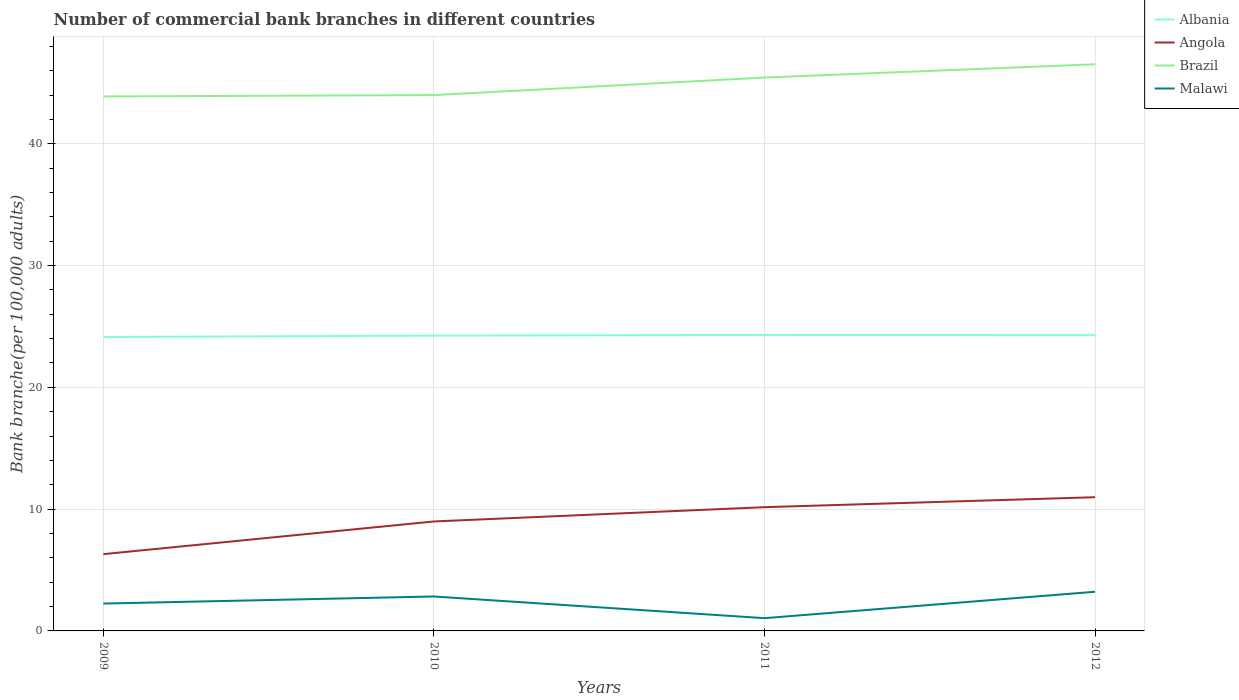How many different coloured lines are there?
Offer a very short reply. 4. Does the line corresponding to Brazil intersect with the line corresponding to Malawi?
Offer a very short reply. No. Is the number of lines equal to the number of legend labels?
Provide a short and direct response. Yes. Across all years, what is the maximum number of commercial bank branches in Angola?
Offer a very short reply. 6.3. In which year was the number of commercial bank branches in Malawi maximum?
Your response must be concise. 2011. What is the total number of commercial bank branches in Angola in the graph?
Your answer should be compact. -1.17. What is the difference between the highest and the second highest number of commercial bank branches in Albania?
Ensure brevity in your answer.  0.17. What is the difference between the highest and the lowest number of commercial bank branches in Brazil?
Offer a terse response. 2. Is the number of commercial bank branches in Angola strictly greater than the number of commercial bank branches in Malawi over the years?
Keep it short and to the point. No. What is the difference between two consecutive major ticks on the Y-axis?
Make the answer very short. 10. Are the values on the major ticks of Y-axis written in scientific E-notation?
Provide a succinct answer. No. Does the graph contain any zero values?
Keep it short and to the point. No. Does the graph contain grids?
Make the answer very short. Yes. How many legend labels are there?
Your answer should be very brief. 4. How are the legend labels stacked?
Your answer should be compact. Vertical. What is the title of the graph?
Your answer should be compact. Number of commercial bank branches in different countries. Does "Myanmar" appear as one of the legend labels in the graph?
Keep it short and to the point. No. What is the label or title of the Y-axis?
Your answer should be compact. Bank branche(per 100,0 adults). What is the Bank branche(per 100,000 adults) of Albania in 2009?
Make the answer very short. 24.13. What is the Bank branche(per 100,000 adults) in Angola in 2009?
Your answer should be compact. 6.3. What is the Bank branche(per 100,000 adults) of Brazil in 2009?
Give a very brief answer. 43.88. What is the Bank branche(per 100,000 adults) of Malawi in 2009?
Your response must be concise. 2.25. What is the Bank branche(per 100,000 adults) of Albania in 2010?
Make the answer very short. 24.24. What is the Bank branche(per 100,000 adults) in Angola in 2010?
Your response must be concise. 8.99. What is the Bank branche(per 100,000 adults) in Brazil in 2010?
Offer a terse response. 43.99. What is the Bank branche(per 100,000 adults) in Malawi in 2010?
Provide a succinct answer. 2.83. What is the Bank branche(per 100,000 adults) in Albania in 2011?
Your response must be concise. 24.3. What is the Bank branche(per 100,000 adults) of Angola in 2011?
Provide a short and direct response. 10.16. What is the Bank branche(per 100,000 adults) in Brazil in 2011?
Make the answer very short. 45.43. What is the Bank branche(per 100,000 adults) in Malawi in 2011?
Give a very brief answer. 1.05. What is the Bank branche(per 100,000 adults) of Albania in 2012?
Give a very brief answer. 24.28. What is the Bank branche(per 100,000 adults) of Angola in 2012?
Make the answer very short. 10.98. What is the Bank branche(per 100,000 adults) in Brazil in 2012?
Provide a succinct answer. 46.52. What is the Bank branche(per 100,000 adults) in Malawi in 2012?
Give a very brief answer. 3.22. Across all years, what is the maximum Bank branche(per 100,000 adults) of Albania?
Offer a very short reply. 24.3. Across all years, what is the maximum Bank branche(per 100,000 adults) in Angola?
Offer a terse response. 10.98. Across all years, what is the maximum Bank branche(per 100,000 adults) of Brazil?
Provide a short and direct response. 46.52. Across all years, what is the maximum Bank branche(per 100,000 adults) of Malawi?
Ensure brevity in your answer.  3.22. Across all years, what is the minimum Bank branche(per 100,000 adults) of Albania?
Keep it short and to the point. 24.13. Across all years, what is the minimum Bank branche(per 100,000 adults) in Angola?
Offer a very short reply. 6.3. Across all years, what is the minimum Bank branche(per 100,000 adults) in Brazil?
Offer a terse response. 43.88. Across all years, what is the minimum Bank branche(per 100,000 adults) in Malawi?
Give a very brief answer. 1.05. What is the total Bank branche(per 100,000 adults) in Albania in the graph?
Give a very brief answer. 96.95. What is the total Bank branche(per 100,000 adults) of Angola in the graph?
Offer a very short reply. 36.43. What is the total Bank branche(per 100,000 adults) of Brazil in the graph?
Make the answer very short. 179.83. What is the total Bank branche(per 100,000 adults) in Malawi in the graph?
Offer a very short reply. 9.34. What is the difference between the Bank branche(per 100,000 adults) in Albania in 2009 and that in 2010?
Ensure brevity in your answer.  -0.11. What is the difference between the Bank branche(per 100,000 adults) in Angola in 2009 and that in 2010?
Give a very brief answer. -2.68. What is the difference between the Bank branche(per 100,000 adults) in Brazil in 2009 and that in 2010?
Provide a short and direct response. -0.11. What is the difference between the Bank branche(per 100,000 adults) in Malawi in 2009 and that in 2010?
Make the answer very short. -0.58. What is the difference between the Bank branche(per 100,000 adults) of Albania in 2009 and that in 2011?
Ensure brevity in your answer.  -0.17. What is the difference between the Bank branche(per 100,000 adults) of Angola in 2009 and that in 2011?
Ensure brevity in your answer.  -3.86. What is the difference between the Bank branche(per 100,000 adults) of Brazil in 2009 and that in 2011?
Provide a succinct answer. -1.55. What is the difference between the Bank branche(per 100,000 adults) of Malawi in 2009 and that in 2011?
Make the answer very short. 1.2. What is the difference between the Bank branche(per 100,000 adults) in Albania in 2009 and that in 2012?
Keep it short and to the point. -0.15. What is the difference between the Bank branche(per 100,000 adults) in Angola in 2009 and that in 2012?
Give a very brief answer. -4.67. What is the difference between the Bank branche(per 100,000 adults) in Brazil in 2009 and that in 2012?
Provide a succinct answer. -2.64. What is the difference between the Bank branche(per 100,000 adults) in Malawi in 2009 and that in 2012?
Offer a terse response. -0.97. What is the difference between the Bank branche(per 100,000 adults) in Albania in 2010 and that in 2011?
Provide a succinct answer. -0.06. What is the difference between the Bank branche(per 100,000 adults) in Angola in 2010 and that in 2011?
Your response must be concise. -1.17. What is the difference between the Bank branche(per 100,000 adults) in Brazil in 2010 and that in 2011?
Ensure brevity in your answer.  -1.44. What is the difference between the Bank branche(per 100,000 adults) in Malawi in 2010 and that in 2011?
Offer a very short reply. 1.78. What is the difference between the Bank branche(per 100,000 adults) in Albania in 2010 and that in 2012?
Offer a very short reply. -0.04. What is the difference between the Bank branche(per 100,000 adults) in Angola in 2010 and that in 2012?
Your response must be concise. -1.99. What is the difference between the Bank branche(per 100,000 adults) of Brazil in 2010 and that in 2012?
Provide a succinct answer. -2.53. What is the difference between the Bank branche(per 100,000 adults) of Malawi in 2010 and that in 2012?
Make the answer very short. -0.39. What is the difference between the Bank branche(per 100,000 adults) of Albania in 2011 and that in 2012?
Keep it short and to the point. 0.02. What is the difference between the Bank branche(per 100,000 adults) of Angola in 2011 and that in 2012?
Give a very brief answer. -0.82. What is the difference between the Bank branche(per 100,000 adults) of Brazil in 2011 and that in 2012?
Give a very brief answer. -1.09. What is the difference between the Bank branche(per 100,000 adults) of Malawi in 2011 and that in 2012?
Your answer should be compact. -2.17. What is the difference between the Bank branche(per 100,000 adults) in Albania in 2009 and the Bank branche(per 100,000 adults) in Angola in 2010?
Your answer should be very brief. 15.15. What is the difference between the Bank branche(per 100,000 adults) of Albania in 2009 and the Bank branche(per 100,000 adults) of Brazil in 2010?
Your response must be concise. -19.86. What is the difference between the Bank branche(per 100,000 adults) in Albania in 2009 and the Bank branche(per 100,000 adults) in Malawi in 2010?
Make the answer very short. 21.31. What is the difference between the Bank branche(per 100,000 adults) of Angola in 2009 and the Bank branche(per 100,000 adults) of Brazil in 2010?
Provide a short and direct response. -37.69. What is the difference between the Bank branche(per 100,000 adults) of Angola in 2009 and the Bank branche(per 100,000 adults) of Malawi in 2010?
Ensure brevity in your answer.  3.48. What is the difference between the Bank branche(per 100,000 adults) in Brazil in 2009 and the Bank branche(per 100,000 adults) in Malawi in 2010?
Your answer should be compact. 41.05. What is the difference between the Bank branche(per 100,000 adults) in Albania in 2009 and the Bank branche(per 100,000 adults) in Angola in 2011?
Give a very brief answer. 13.97. What is the difference between the Bank branche(per 100,000 adults) of Albania in 2009 and the Bank branche(per 100,000 adults) of Brazil in 2011?
Your answer should be very brief. -21.3. What is the difference between the Bank branche(per 100,000 adults) of Albania in 2009 and the Bank branche(per 100,000 adults) of Malawi in 2011?
Ensure brevity in your answer.  23.09. What is the difference between the Bank branche(per 100,000 adults) of Angola in 2009 and the Bank branche(per 100,000 adults) of Brazil in 2011?
Make the answer very short. -39.13. What is the difference between the Bank branche(per 100,000 adults) of Angola in 2009 and the Bank branche(per 100,000 adults) of Malawi in 2011?
Your answer should be very brief. 5.26. What is the difference between the Bank branche(per 100,000 adults) of Brazil in 2009 and the Bank branche(per 100,000 adults) of Malawi in 2011?
Offer a very short reply. 42.83. What is the difference between the Bank branche(per 100,000 adults) in Albania in 2009 and the Bank branche(per 100,000 adults) in Angola in 2012?
Your answer should be compact. 13.16. What is the difference between the Bank branche(per 100,000 adults) of Albania in 2009 and the Bank branche(per 100,000 adults) of Brazil in 2012?
Your response must be concise. -22.39. What is the difference between the Bank branche(per 100,000 adults) in Albania in 2009 and the Bank branche(per 100,000 adults) in Malawi in 2012?
Make the answer very short. 20.92. What is the difference between the Bank branche(per 100,000 adults) in Angola in 2009 and the Bank branche(per 100,000 adults) in Brazil in 2012?
Provide a succinct answer. -40.22. What is the difference between the Bank branche(per 100,000 adults) of Angola in 2009 and the Bank branche(per 100,000 adults) of Malawi in 2012?
Make the answer very short. 3.09. What is the difference between the Bank branche(per 100,000 adults) in Brazil in 2009 and the Bank branche(per 100,000 adults) in Malawi in 2012?
Provide a succinct answer. 40.67. What is the difference between the Bank branche(per 100,000 adults) in Albania in 2010 and the Bank branche(per 100,000 adults) in Angola in 2011?
Provide a short and direct response. 14.08. What is the difference between the Bank branche(per 100,000 adults) in Albania in 2010 and the Bank branche(per 100,000 adults) in Brazil in 2011?
Ensure brevity in your answer.  -21.19. What is the difference between the Bank branche(per 100,000 adults) of Albania in 2010 and the Bank branche(per 100,000 adults) of Malawi in 2011?
Give a very brief answer. 23.2. What is the difference between the Bank branche(per 100,000 adults) in Angola in 2010 and the Bank branche(per 100,000 adults) in Brazil in 2011?
Give a very brief answer. -36.45. What is the difference between the Bank branche(per 100,000 adults) in Angola in 2010 and the Bank branche(per 100,000 adults) in Malawi in 2011?
Give a very brief answer. 7.94. What is the difference between the Bank branche(per 100,000 adults) of Brazil in 2010 and the Bank branche(per 100,000 adults) of Malawi in 2011?
Your response must be concise. 42.95. What is the difference between the Bank branche(per 100,000 adults) of Albania in 2010 and the Bank branche(per 100,000 adults) of Angola in 2012?
Provide a succinct answer. 13.27. What is the difference between the Bank branche(per 100,000 adults) of Albania in 2010 and the Bank branche(per 100,000 adults) of Brazil in 2012?
Provide a succinct answer. -22.28. What is the difference between the Bank branche(per 100,000 adults) in Albania in 2010 and the Bank branche(per 100,000 adults) in Malawi in 2012?
Offer a very short reply. 21.03. What is the difference between the Bank branche(per 100,000 adults) of Angola in 2010 and the Bank branche(per 100,000 adults) of Brazil in 2012?
Keep it short and to the point. -37.54. What is the difference between the Bank branche(per 100,000 adults) in Angola in 2010 and the Bank branche(per 100,000 adults) in Malawi in 2012?
Your answer should be compact. 5.77. What is the difference between the Bank branche(per 100,000 adults) of Brazil in 2010 and the Bank branche(per 100,000 adults) of Malawi in 2012?
Provide a short and direct response. 40.78. What is the difference between the Bank branche(per 100,000 adults) of Albania in 2011 and the Bank branche(per 100,000 adults) of Angola in 2012?
Your response must be concise. 13.32. What is the difference between the Bank branche(per 100,000 adults) in Albania in 2011 and the Bank branche(per 100,000 adults) in Brazil in 2012?
Provide a succinct answer. -22.22. What is the difference between the Bank branche(per 100,000 adults) in Albania in 2011 and the Bank branche(per 100,000 adults) in Malawi in 2012?
Offer a terse response. 21.08. What is the difference between the Bank branche(per 100,000 adults) in Angola in 2011 and the Bank branche(per 100,000 adults) in Brazil in 2012?
Keep it short and to the point. -36.36. What is the difference between the Bank branche(per 100,000 adults) in Angola in 2011 and the Bank branche(per 100,000 adults) in Malawi in 2012?
Your answer should be very brief. 6.94. What is the difference between the Bank branche(per 100,000 adults) of Brazil in 2011 and the Bank branche(per 100,000 adults) of Malawi in 2012?
Offer a terse response. 42.22. What is the average Bank branche(per 100,000 adults) in Albania per year?
Your answer should be very brief. 24.24. What is the average Bank branche(per 100,000 adults) in Angola per year?
Give a very brief answer. 9.11. What is the average Bank branche(per 100,000 adults) in Brazil per year?
Offer a terse response. 44.96. What is the average Bank branche(per 100,000 adults) in Malawi per year?
Provide a short and direct response. 2.33. In the year 2009, what is the difference between the Bank branche(per 100,000 adults) in Albania and Bank branche(per 100,000 adults) in Angola?
Provide a short and direct response. 17.83. In the year 2009, what is the difference between the Bank branche(per 100,000 adults) in Albania and Bank branche(per 100,000 adults) in Brazil?
Provide a short and direct response. -19.75. In the year 2009, what is the difference between the Bank branche(per 100,000 adults) of Albania and Bank branche(per 100,000 adults) of Malawi?
Provide a succinct answer. 21.89. In the year 2009, what is the difference between the Bank branche(per 100,000 adults) in Angola and Bank branche(per 100,000 adults) in Brazil?
Ensure brevity in your answer.  -37.58. In the year 2009, what is the difference between the Bank branche(per 100,000 adults) of Angola and Bank branche(per 100,000 adults) of Malawi?
Provide a succinct answer. 4.06. In the year 2009, what is the difference between the Bank branche(per 100,000 adults) of Brazil and Bank branche(per 100,000 adults) of Malawi?
Ensure brevity in your answer.  41.63. In the year 2010, what is the difference between the Bank branche(per 100,000 adults) in Albania and Bank branche(per 100,000 adults) in Angola?
Ensure brevity in your answer.  15.26. In the year 2010, what is the difference between the Bank branche(per 100,000 adults) in Albania and Bank branche(per 100,000 adults) in Brazil?
Your response must be concise. -19.75. In the year 2010, what is the difference between the Bank branche(per 100,000 adults) of Albania and Bank branche(per 100,000 adults) of Malawi?
Your answer should be very brief. 21.42. In the year 2010, what is the difference between the Bank branche(per 100,000 adults) in Angola and Bank branche(per 100,000 adults) in Brazil?
Ensure brevity in your answer.  -35.01. In the year 2010, what is the difference between the Bank branche(per 100,000 adults) in Angola and Bank branche(per 100,000 adults) in Malawi?
Your response must be concise. 6.16. In the year 2010, what is the difference between the Bank branche(per 100,000 adults) of Brazil and Bank branche(per 100,000 adults) of Malawi?
Make the answer very short. 41.17. In the year 2011, what is the difference between the Bank branche(per 100,000 adults) of Albania and Bank branche(per 100,000 adults) of Angola?
Your response must be concise. 14.14. In the year 2011, what is the difference between the Bank branche(per 100,000 adults) in Albania and Bank branche(per 100,000 adults) in Brazil?
Keep it short and to the point. -21.13. In the year 2011, what is the difference between the Bank branche(per 100,000 adults) of Albania and Bank branche(per 100,000 adults) of Malawi?
Your answer should be very brief. 23.25. In the year 2011, what is the difference between the Bank branche(per 100,000 adults) in Angola and Bank branche(per 100,000 adults) in Brazil?
Provide a succinct answer. -35.27. In the year 2011, what is the difference between the Bank branche(per 100,000 adults) of Angola and Bank branche(per 100,000 adults) of Malawi?
Provide a succinct answer. 9.11. In the year 2011, what is the difference between the Bank branche(per 100,000 adults) of Brazil and Bank branche(per 100,000 adults) of Malawi?
Make the answer very short. 44.39. In the year 2012, what is the difference between the Bank branche(per 100,000 adults) of Albania and Bank branche(per 100,000 adults) of Angola?
Offer a very short reply. 13.3. In the year 2012, what is the difference between the Bank branche(per 100,000 adults) of Albania and Bank branche(per 100,000 adults) of Brazil?
Offer a very short reply. -22.24. In the year 2012, what is the difference between the Bank branche(per 100,000 adults) in Albania and Bank branche(per 100,000 adults) in Malawi?
Make the answer very short. 21.06. In the year 2012, what is the difference between the Bank branche(per 100,000 adults) in Angola and Bank branche(per 100,000 adults) in Brazil?
Your answer should be very brief. -35.55. In the year 2012, what is the difference between the Bank branche(per 100,000 adults) in Angola and Bank branche(per 100,000 adults) in Malawi?
Your response must be concise. 7.76. In the year 2012, what is the difference between the Bank branche(per 100,000 adults) of Brazil and Bank branche(per 100,000 adults) of Malawi?
Ensure brevity in your answer.  43.31. What is the ratio of the Bank branche(per 100,000 adults) of Albania in 2009 to that in 2010?
Ensure brevity in your answer.  1. What is the ratio of the Bank branche(per 100,000 adults) in Angola in 2009 to that in 2010?
Your response must be concise. 0.7. What is the ratio of the Bank branche(per 100,000 adults) of Brazil in 2009 to that in 2010?
Ensure brevity in your answer.  1. What is the ratio of the Bank branche(per 100,000 adults) of Malawi in 2009 to that in 2010?
Keep it short and to the point. 0.79. What is the ratio of the Bank branche(per 100,000 adults) in Angola in 2009 to that in 2011?
Ensure brevity in your answer.  0.62. What is the ratio of the Bank branche(per 100,000 adults) of Brazil in 2009 to that in 2011?
Make the answer very short. 0.97. What is the ratio of the Bank branche(per 100,000 adults) of Malawi in 2009 to that in 2011?
Keep it short and to the point. 2.14. What is the ratio of the Bank branche(per 100,000 adults) in Albania in 2009 to that in 2012?
Offer a terse response. 0.99. What is the ratio of the Bank branche(per 100,000 adults) in Angola in 2009 to that in 2012?
Your response must be concise. 0.57. What is the ratio of the Bank branche(per 100,000 adults) of Brazil in 2009 to that in 2012?
Offer a very short reply. 0.94. What is the ratio of the Bank branche(per 100,000 adults) of Malawi in 2009 to that in 2012?
Ensure brevity in your answer.  0.7. What is the ratio of the Bank branche(per 100,000 adults) of Angola in 2010 to that in 2011?
Provide a succinct answer. 0.88. What is the ratio of the Bank branche(per 100,000 adults) of Brazil in 2010 to that in 2011?
Your answer should be compact. 0.97. What is the ratio of the Bank branche(per 100,000 adults) of Malawi in 2010 to that in 2011?
Your answer should be compact. 2.7. What is the ratio of the Bank branche(per 100,000 adults) of Angola in 2010 to that in 2012?
Give a very brief answer. 0.82. What is the ratio of the Bank branche(per 100,000 adults) of Brazil in 2010 to that in 2012?
Your answer should be compact. 0.95. What is the ratio of the Bank branche(per 100,000 adults) in Malawi in 2010 to that in 2012?
Offer a very short reply. 0.88. What is the ratio of the Bank branche(per 100,000 adults) of Albania in 2011 to that in 2012?
Offer a very short reply. 1. What is the ratio of the Bank branche(per 100,000 adults) of Angola in 2011 to that in 2012?
Your answer should be very brief. 0.93. What is the ratio of the Bank branche(per 100,000 adults) of Brazil in 2011 to that in 2012?
Your answer should be very brief. 0.98. What is the ratio of the Bank branche(per 100,000 adults) of Malawi in 2011 to that in 2012?
Offer a terse response. 0.33. What is the difference between the highest and the second highest Bank branche(per 100,000 adults) of Albania?
Provide a succinct answer. 0.02. What is the difference between the highest and the second highest Bank branche(per 100,000 adults) of Angola?
Provide a succinct answer. 0.82. What is the difference between the highest and the second highest Bank branche(per 100,000 adults) in Brazil?
Ensure brevity in your answer.  1.09. What is the difference between the highest and the second highest Bank branche(per 100,000 adults) in Malawi?
Keep it short and to the point. 0.39. What is the difference between the highest and the lowest Bank branche(per 100,000 adults) in Albania?
Your response must be concise. 0.17. What is the difference between the highest and the lowest Bank branche(per 100,000 adults) of Angola?
Offer a very short reply. 4.67. What is the difference between the highest and the lowest Bank branche(per 100,000 adults) in Brazil?
Your response must be concise. 2.64. What is the difference between the highest and the lowest Bank branche(per 100,000 adults) of Malawi?
Offer a very short reply. 2.17. 